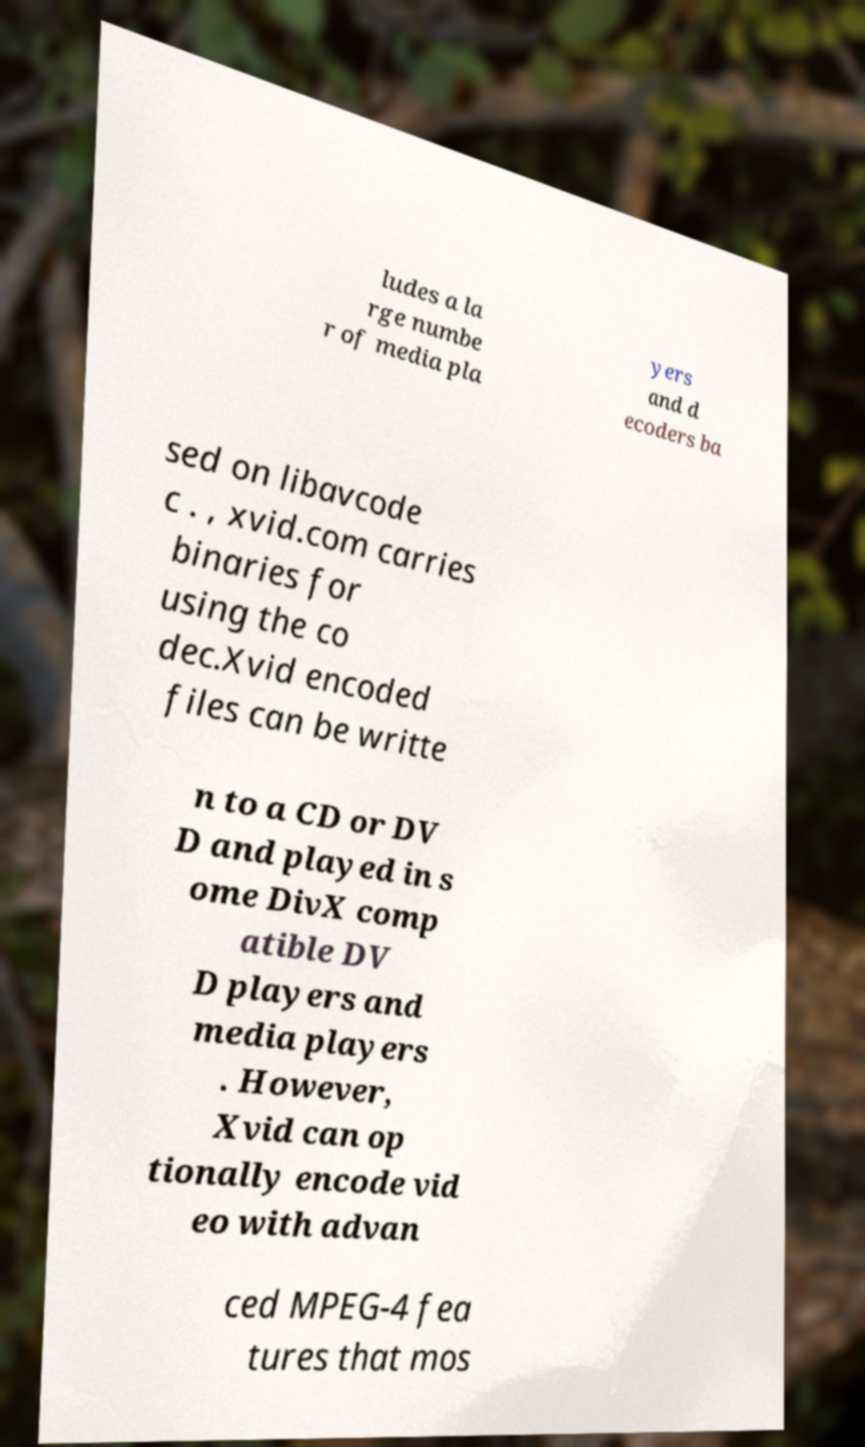Can you accurately transcribe the text from the provided image for me? ludes a la rge numbe r of media pla yers and d ecoders ba sed on libavcode c . , xvid.com carries binaries for using the co dec.Xvid encoded files can be writte n to a CD or DV D and played in s ome DivX comp atible DV D players and media players . However, Xvid can op tionally encode vid eo with advan ced MPEG-4 fea tures that mos 